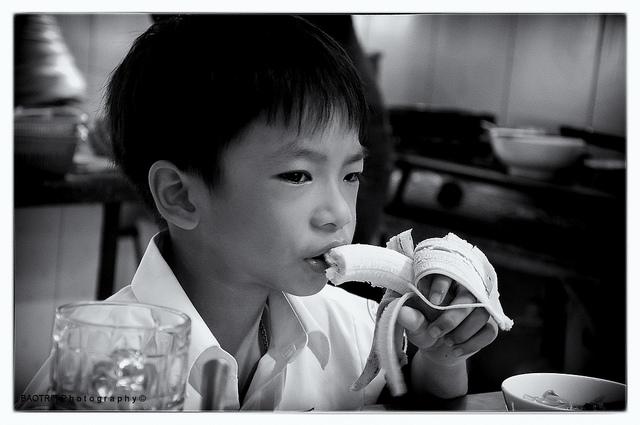Does the boy look content?
Be succinct. Yes. What is the boy eating?
Quick response, please. Banana. What color is the boy's hair?
Quick response, please. Black. 